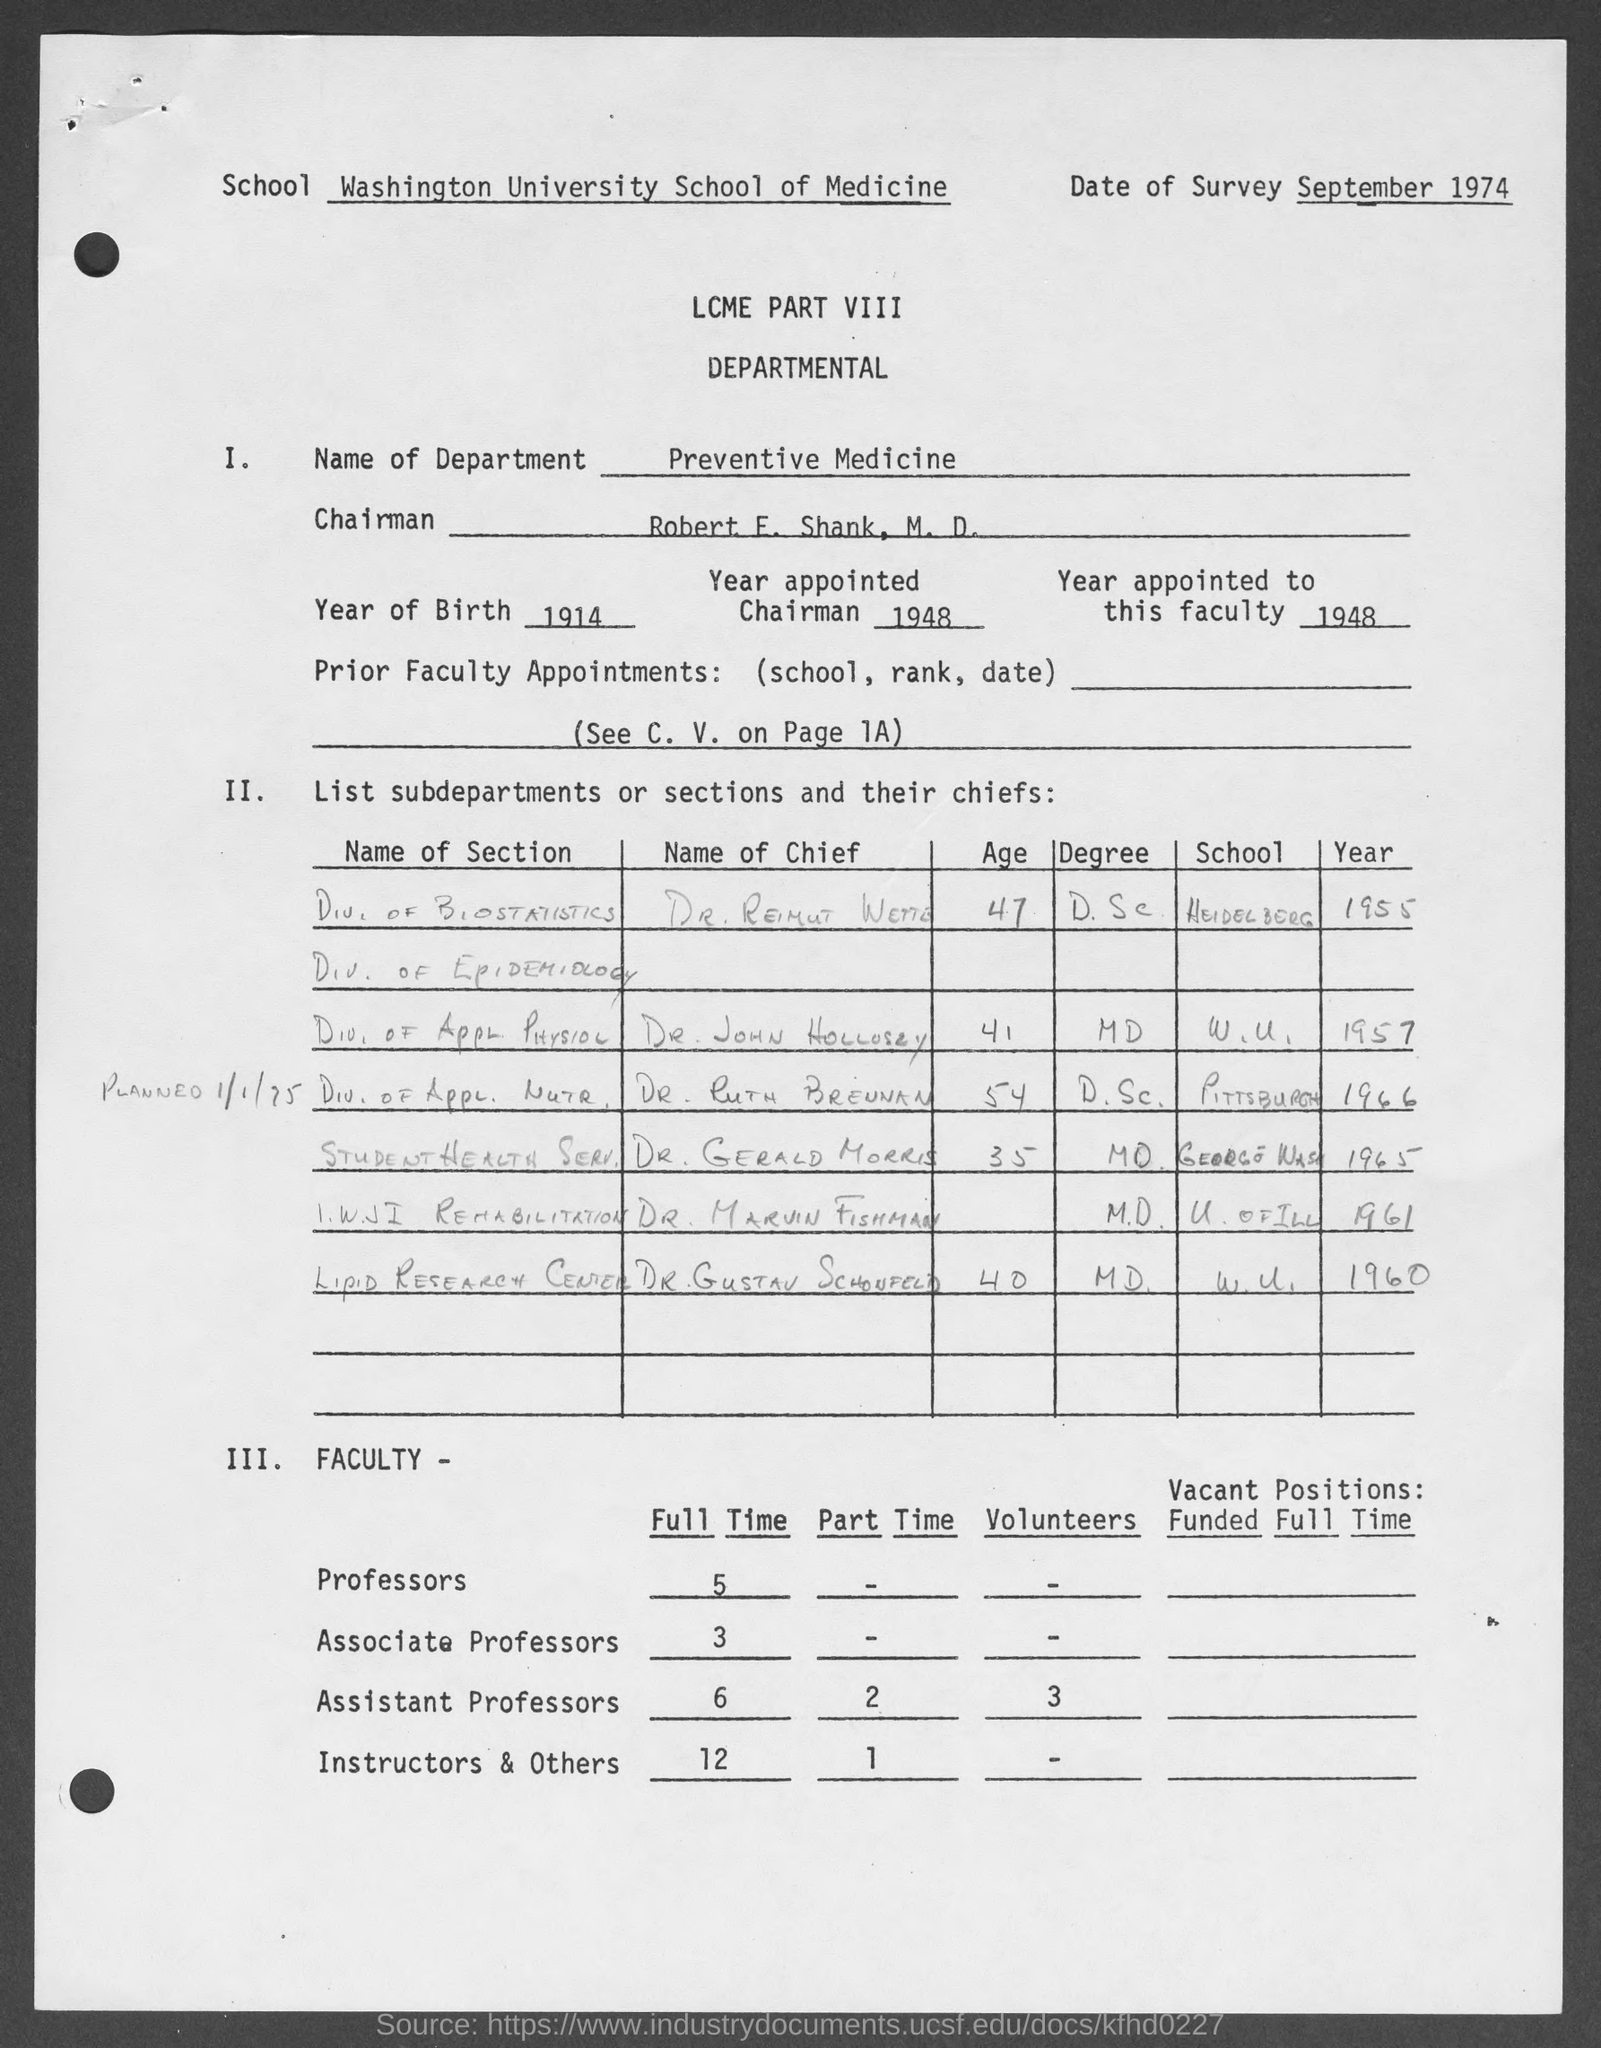List a handful of essential elements in this visual. The year of birth mentioned on the given page is 1914. There are three full-time associate professors mentioned on the given page. The year appointed to this faculty, as mentioned in the given form, is 1948. The Washington University School of Medicine is the name of the school mentioned in the given form. According to the given page, there are 6 full-time assistant professors. 